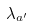<formula> <loc_0><loc_0><loc_500><loc_500>\lambda _ { a ^ { \prime } } { { } }</formula> 